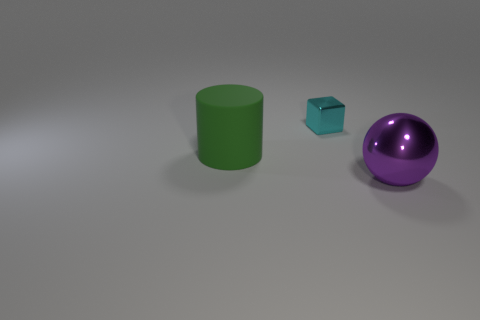What number of objects are either big rubber cylinders or small cyan shiny blocks?
Offer a very short reply. 2. Are there any green things of the same size as the cylinder?
Offer a terse response. No. The green matte thing is what shape?
Your response must be concise. Cylinder. Is the number of big purple metal objects behind the big shiny sphere greater than the number of large purple spheres that are behind the tiny cyan object?
Your response must be concise. No. There is a metal thing in front of the green object; is its color the same as the object behind the green cylinder?
Give a very brief answer. No. What shape is the purple metal thing that is the same size as the cylinder?
Keep it short and to the point. Sphere. Is there a tiny cyan metallic object of the same shape as the green rubber thing?
Give a very brief answer. No. Is the object that is in front of the green matte object made of the same material as the thing to the left of the cyan metal block?
Your answer should be very brief. No. How many large purple spheres have the same material as the tiny thing?
Offer a terse response. 1. What is the color of the big metallic sphere?
Offer a terse response. Purple. 